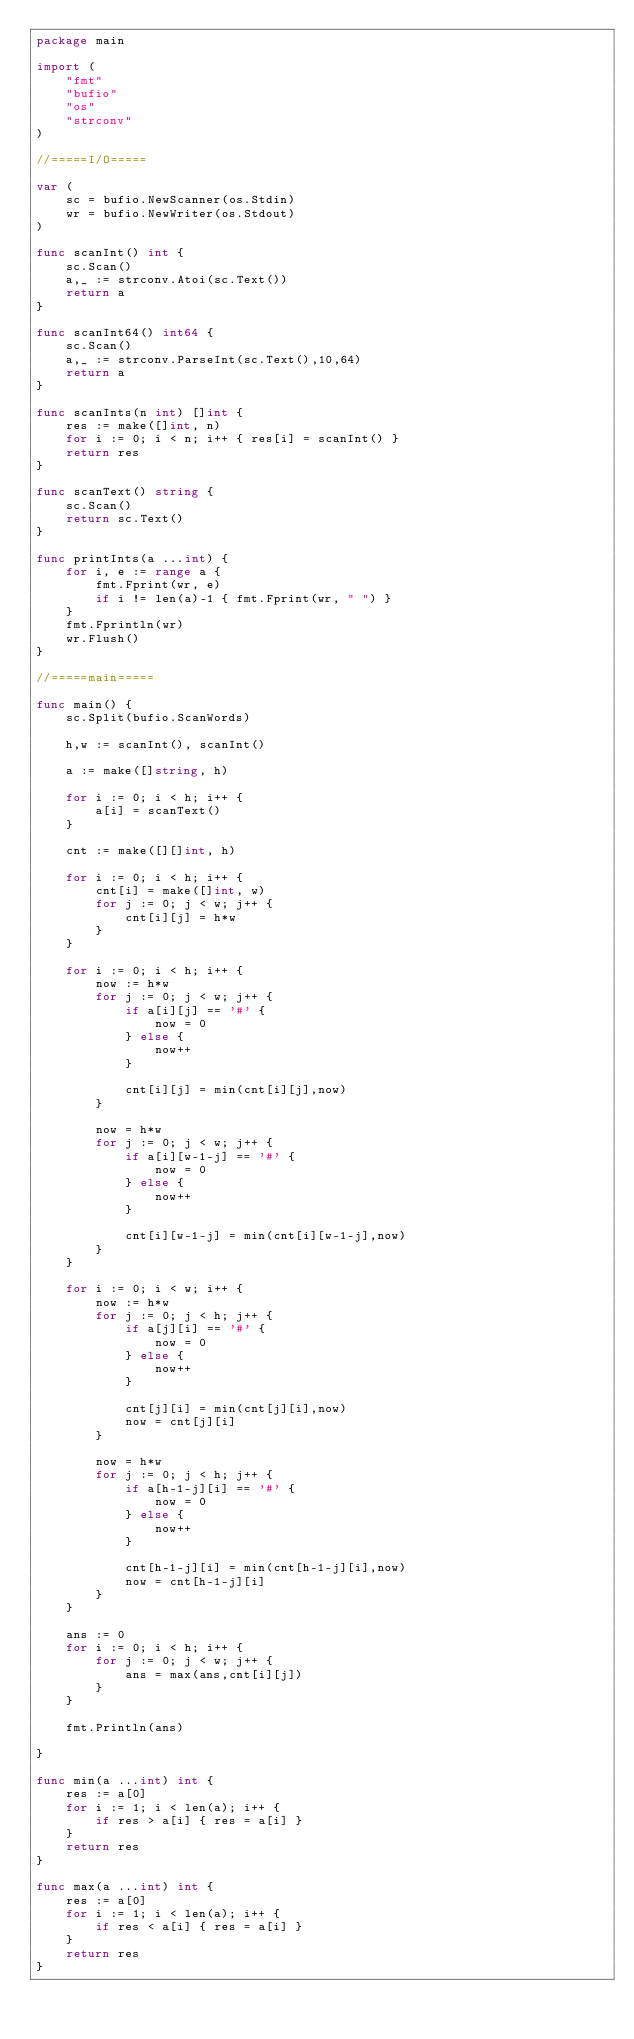<code> <loc_0><loc_0><loc_500><loc_500><_Go_>package main

import (
	"fmt"
	"bufio"
	"os"
	"strconv"
)

//=====I/O=====

var (
	sc = bufio.NewScanner(os.Stdin)
	wr = bufio.NewWriter(os.Stdout)
)

func scanInt() int {
	sc.Scan()
	a,_ := strconv.Atoi(sc.Text())
	return a
}

func scanInt64() int64 {
	sc.Scan()
	a,_ := strconv.ParseInt(sc.Text(),10,64)
	return a
}

func scanInts(n int) []int {
	res := make([]int, n)
	for i := 0; i < n; i++ { res[i] = scanInt() }
	return res
}

func scanText() string {
	sc.Scan()
	return sc.Text()
}

func printInts(a ...int) {
	for i, e := range a {
		fmt.Fprint(wr, e)
		if i != len(a)-1 { fmt.Fprint(wr, " ") }
	}
	fmt.Fprintln(wr)
	wr.Flush()
}

//=====main=====

func main() {
	sc.Split(bufio.ScanWords)

	h,w := scanInt(), scanInt()

	a := make([]string, h)

	for i := 0; i < h; i++ {
		a[i] = scanText()
	}

	cnt := make([][]int, h)

	for i := 0; i < h; i++ {
		cnt[i] = make([]int, w)
		for j := 0; j < w; j++ {
			cnt[i][j] = h*w
		}
	}

	for i := 0; i < h; i++ {
		now := h*w
		for j := 0; j < w; j++ {
			if a[i][j] == '#' {
				now = 0
			} else {
				now++
			}

			cnt[i][j] = min(cnt[i][j],now)
		}

		now = h*w
		for j := 0; j < w; j++ {
			if a[i][w-1-j] == '#' {
				now = 0
			} else {
				now++
			}

			cnt[i][w-1-j] = min(cnt[i][w-1-j],now)
		}
	}

	for i := 0; i < w; i++ {
		now := h*w
		for j := 0; j < h; j++ {
			if a[j][i] == '#' {
				now = 0
			} else {
				now++
			}

			cnt[j][i] = min(cnt[j][i],now)
			now = cnt[j][i]
		}

		now = h*w
		for j := 0; j < h; j++ {
			if a[h-1-j][i] == '#' {
				now = 0
			} else {
				now++
			}

			cnt[h-1-j][i] = min(cnt[h-1-j][i],now)
			now = cnt[h-1-j][i]
		}
	}

	ans := 0
	for i := 0; i < h; i++ {
		for j := 0; j < w; j++ {
			ans = max(ans,cnt[i][j])
		}
	}

	fmt.Println(ans)

}

func min(a ...int) int {
	res := a[0]
	for i := 1; i < len(a); i++ {
		if res > a[i] { res = a[i] }
	}
	return res
}

func max(a ...int) int {
	res := a[0]
	for i := 1; i < len(a); i++ {
		if res < a[i] { res = a[i] }
	}
	return res
}
</code> 